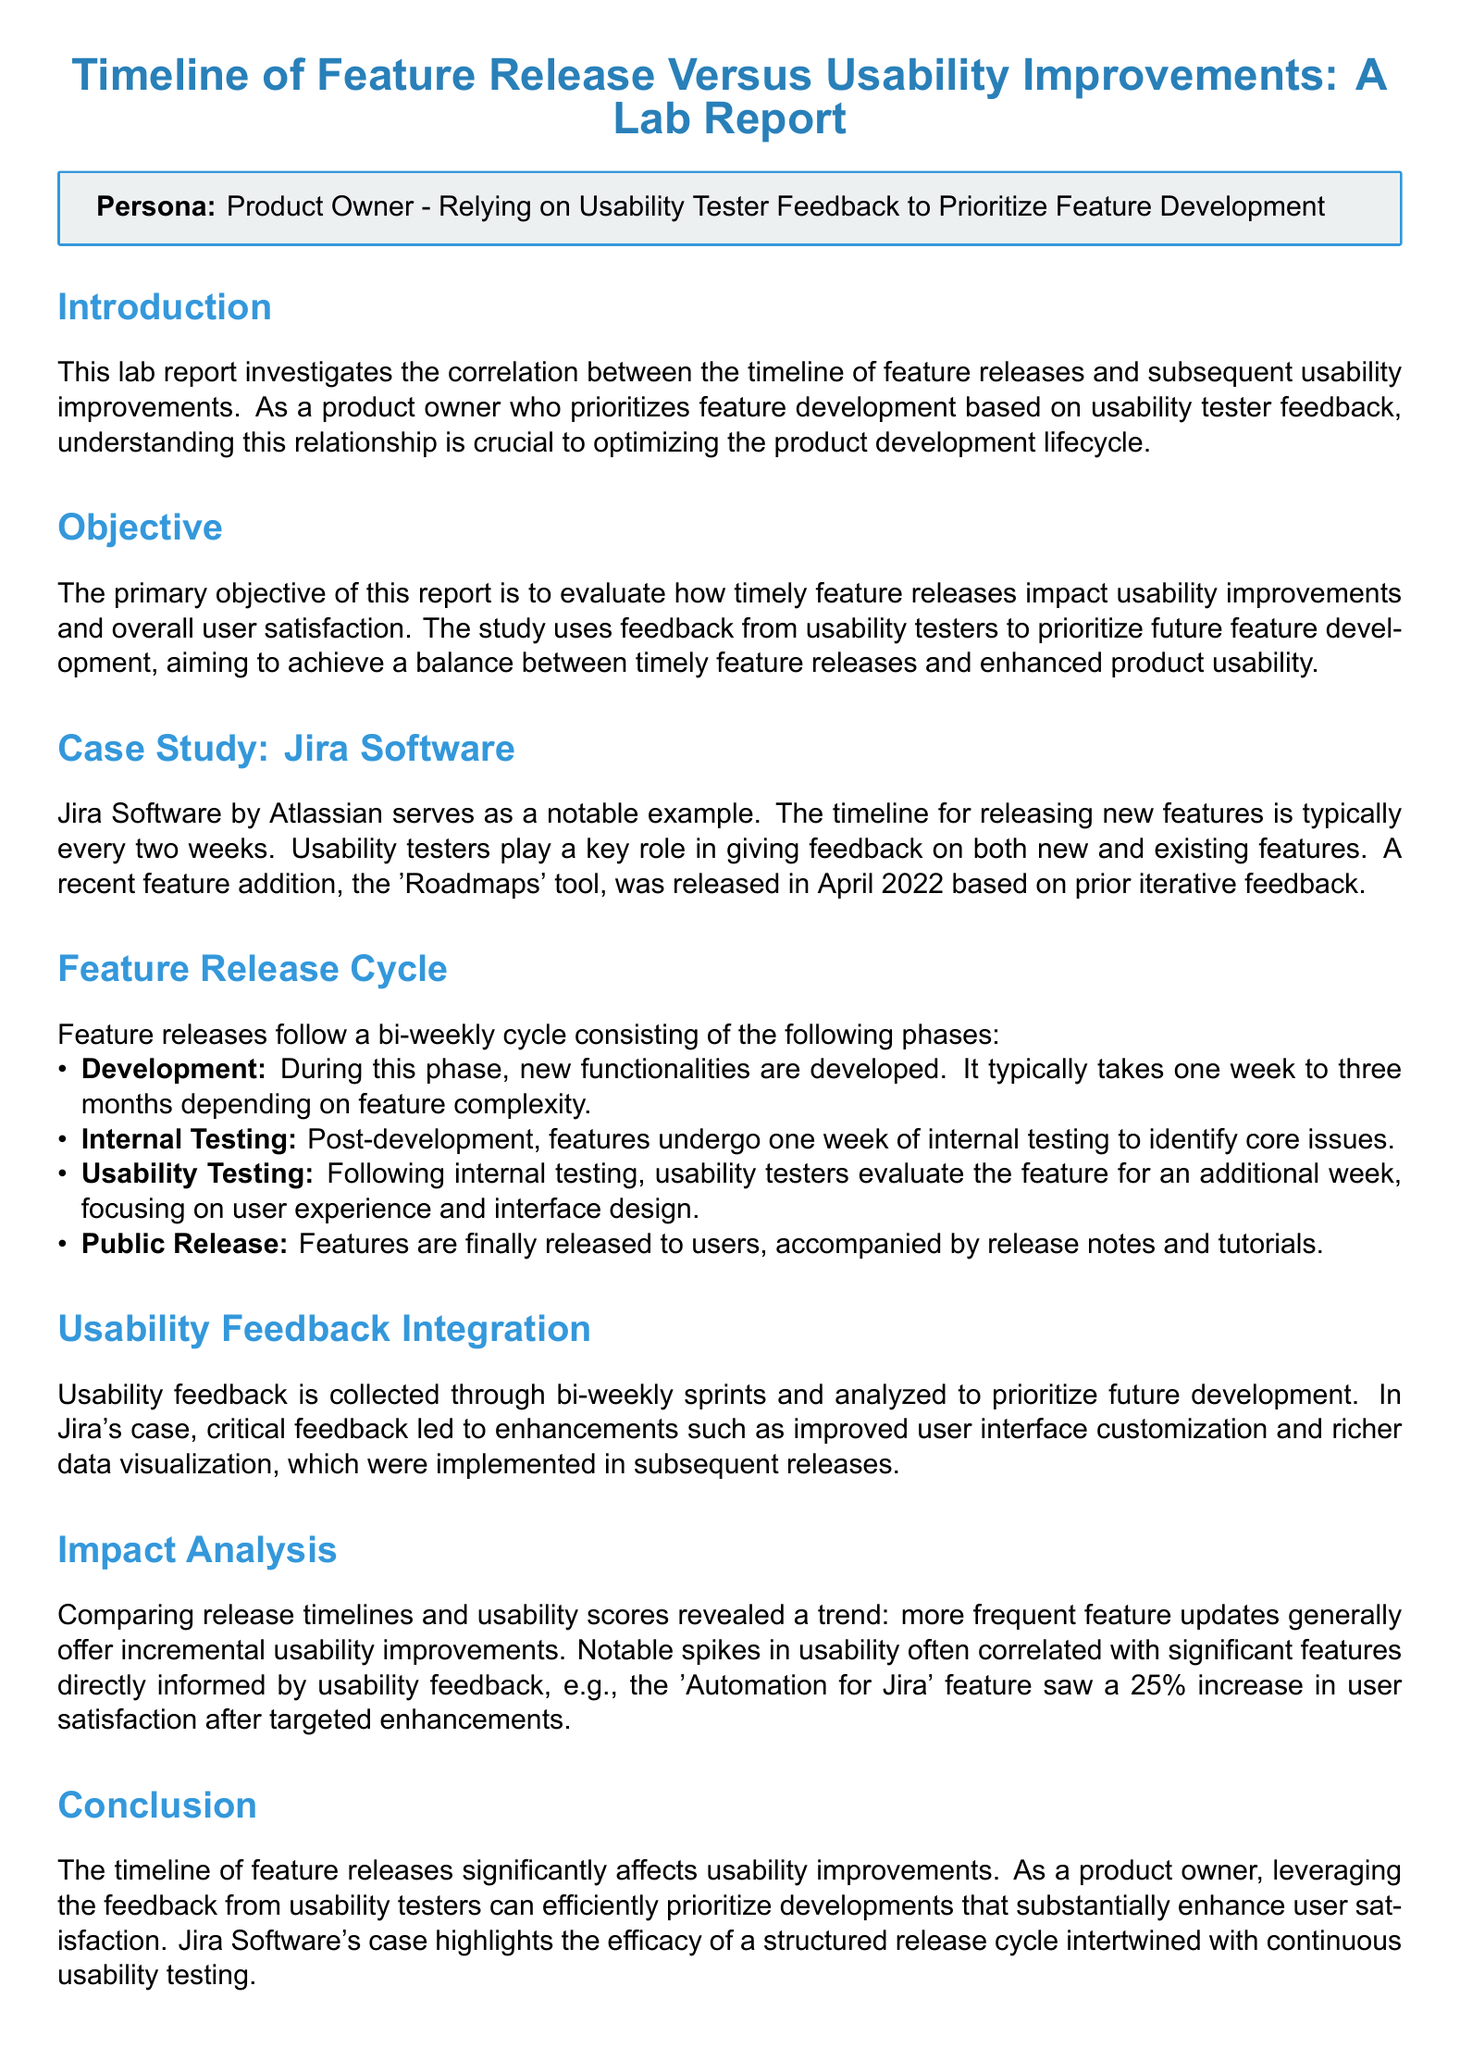What is the product being analyzed in the case study? The document identifies Jira Software by Atlassian as the product case study of interest.
Answer: Jira Software What is the typical feature release cycle for Jira Software? The document mentions that features are typically released every two weeks.
Answer: Two weeks What feature was released in April 2022? The 'Roadmaps' tool is mentioned as being released in April 2022 based on prior feedback.
Answer: Roadmaps tool What percentage increase in user satisfaction was noted after enhancing the 'Automation for Jira' feature? The report states that the feature saw a 25% increase in user satisfaction after targeted enhancements.
Answer: 25% What is the first phase of the feature release cycle? The document describes the Development phase as the first phase in the release cycle.
Answer: Development How long does the usability testing phase last? It mentions that the usability testing phase lasts for one week following internal testing.
Answer: One week What was a notable enhancement made based on usability feedback? The report indicates that improved user interface customization was one of the enhancements implemented subsequent to usability feedback.
Answer: Improved user interface customization What is the primary objective of the report? The document states that the primary objective is to evaluate how timely feature releases impact usability improvements and overall user satisfaction.
Answer: Evaluate usability improvements What role do usability testers play in the feature release process? The document explains that usability testers evaluate features focused on user experience and interface design during usability testing.
Answer: Evaluate features 